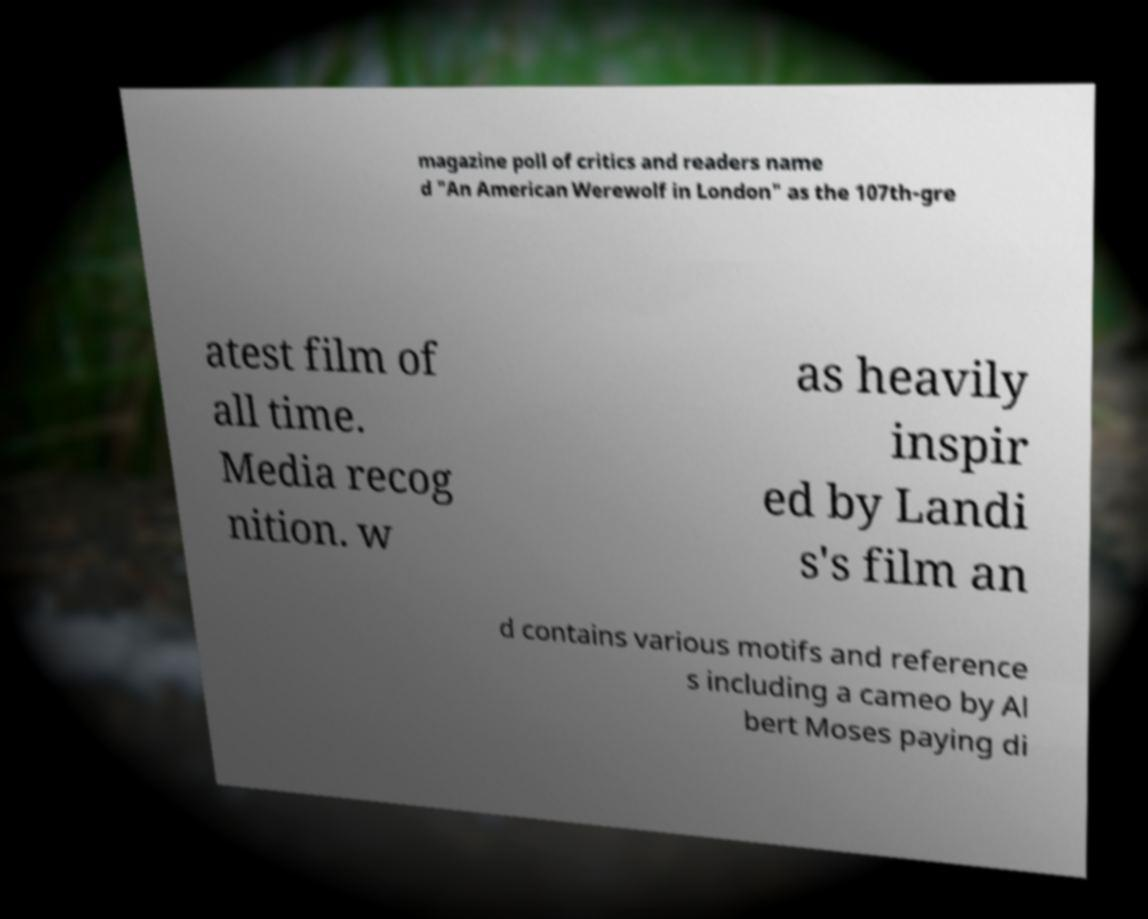I need the written content from this picture converted into text. Can you do that? magazine poll of critics and readers name d "An American Werewolf in London" as the 107th-gre atest film of all time. Media recog nition. w as heavily inspir ed by Landi s's film an d contains various motifs and reference s including a cameo by Al bert Moses paying di 